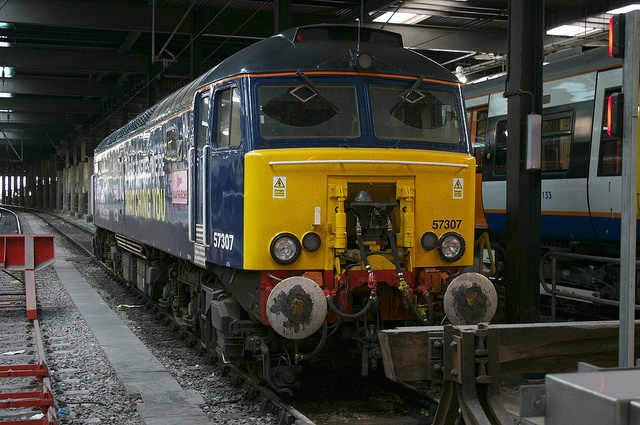Describe the objects in this image and their specific colors. I can see train in black, gray, and olive tones and train in black, gray, and darkgray tones in this image. 